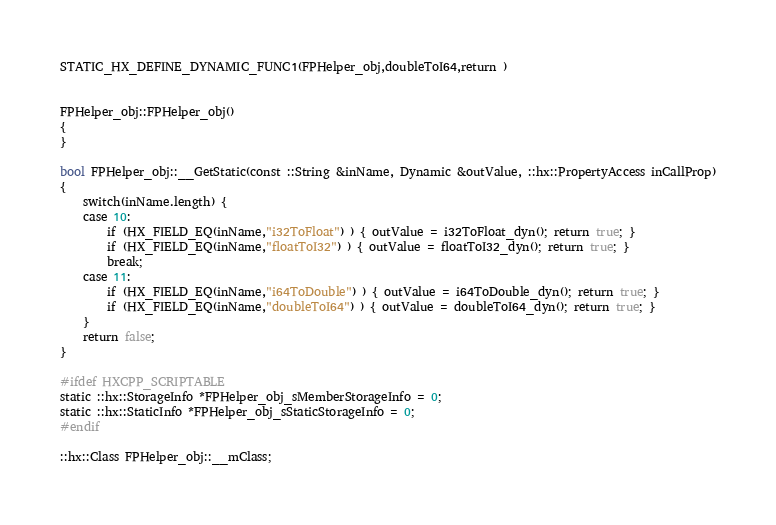Convert code to text. <code><loc_0><loc_0><loc_500><loc_500><_C++_>

STATIC_HX_DEFINE_DYNAMIC_FUNC1(FPHelper_obj,doubleToI64,return )


FPHelper_obj::FPHelper_obj()
{
}

bool FPHelper_obj::__GetStatic(const ::String &inName, Dynamic &outValue, ::hx::PropertyAccess inCallProp)
{
	switch(inName.length) {
	case 10:
		if (HX_FIELD_EQ(inName,"i32ToFloat") ) { outValue = i32ToFloat_dyn(); return true; }
		if (HX_FIELD_EQ(inName,"floatToI32") ) { outValue = floatToI32_dyn(); return true; }
		break;
	case 11:
		if (HX_FIELD_EQ(inName,"i64ToDouble") ) { outValue = i64ToDouble_dyn(); return true; }
		if (HX_FIELD_EQ(inName,"doubleToI64") ) { outValue = doubleToI64_dyn(); return true; }
	}
	return false;
}

#ifdef HXCPP_SCRIPTABLE
static ::hx::StorageInfo *FPHelper_obj_sMemberStorageInfo = 0;
static ::hx::StaticInfo *FPHelper_obj_sStaticStorageInfo = 0;
#endif

::hx::Class FPHelper_obj::__mClass;
</code> 